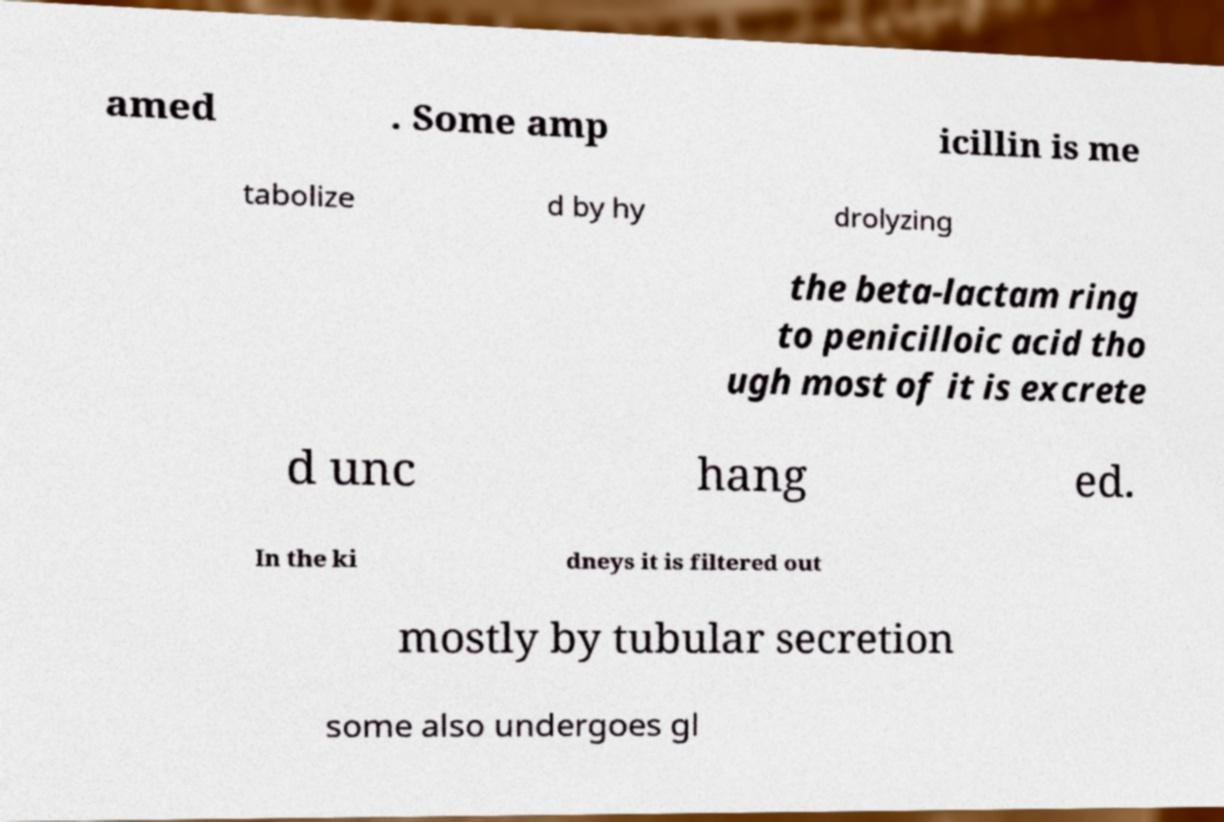Could you assist in decoding the text presented in this image and type it out clearly? amed . Some amp icillin is me tabolize d by hy drolyzing the beta-lactam ring to penicilloic acid tho ugh most of it is excrete d unc hang ed. In the ki dneys it is filtered out mostly by tubular secretion some also undergoes gl 